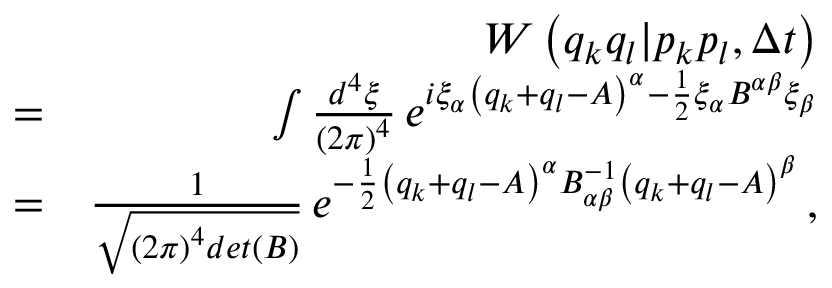<formula> <loc_0><loc_0><loc_500><loc_500>\begin{array} { r l r } & { W \left ( q _ { k } q _ { l } | p _ { k } p _ { l } , \Delta t \right ) } \\ & { = } & { \int \frac { d ^ { 4 } \xi } { \left ( 2 \pi \right ) ^ { 4 } } \, e ^ { i \xi _ { \alpha } \left ( q _ { k } + q _ { l } - A \right ) ^ { \alpha } - \frac { 1 } { 2 } \xi _ { \alpha } B ^ { \alpha \beta } \xi _ { \beta } } } \\ & { = } & { \frac { 1 } { \sqrt { \left ( 2 \pi \right ) ^ { 4 } d e t \left ( B \right ) } } \, e ^ { - \frac { 1 } { 2 } \left ( q _ { k } + q _ { l } - A \right ) ^ { \alpha } B _ { \alpha \beta } ^ { - 1 } \left ( q _ { k } + q _ { l } - A \right ) ^ { \beta } } \, , } \end{array}</formula> 